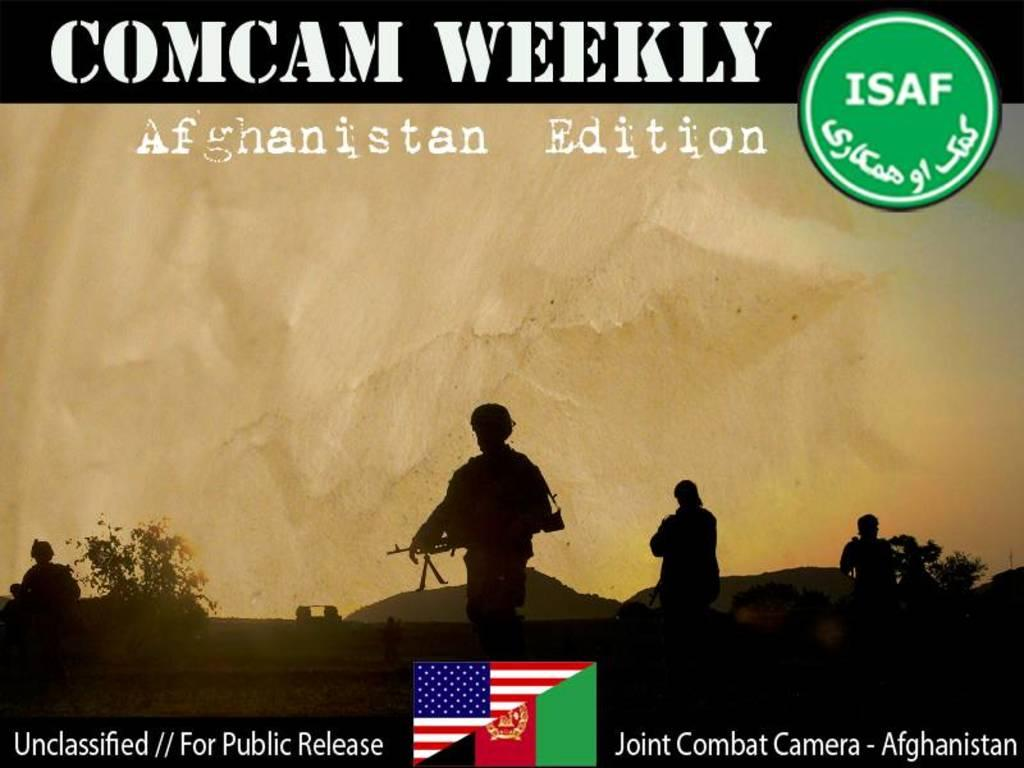<image>
Summarize the visual content of the image. A photograph of soldiers under the heading "comcam weekly". 